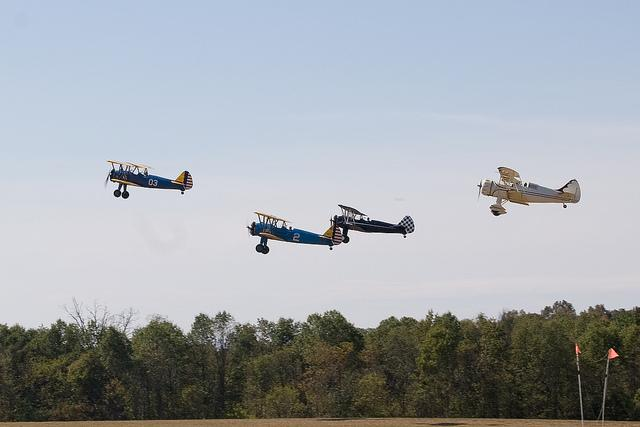What type of activities are happening here? air show 